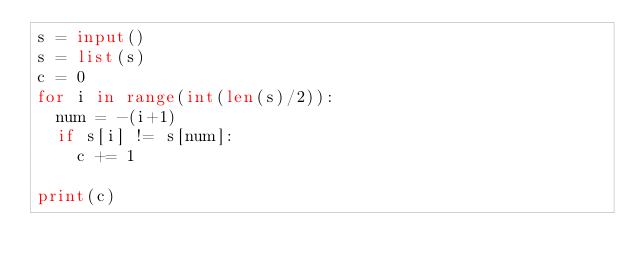Convert code to text. <code><loc_0><loc_0><loc_500><loc_500><_Python_>s = input()
s = list(s)
c = 0
for i in range(int(len(s)/2)):
  num = -(i+1)
  if s[i] != s[num]:
    c += 1
    
print(c)</code> 